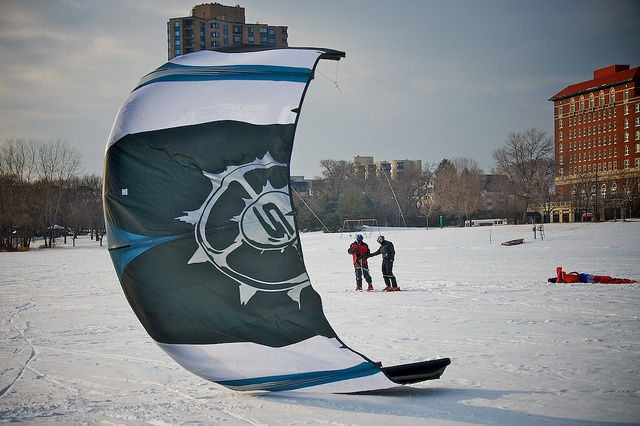Describe the objects in this image and their specific colors. I can see kite in gray, black, blue, darkgray, and darkblue tones, people in gray, black, maroon, and brown tones, and people in gray, black, lightgray, and darkgray tones in this image. 